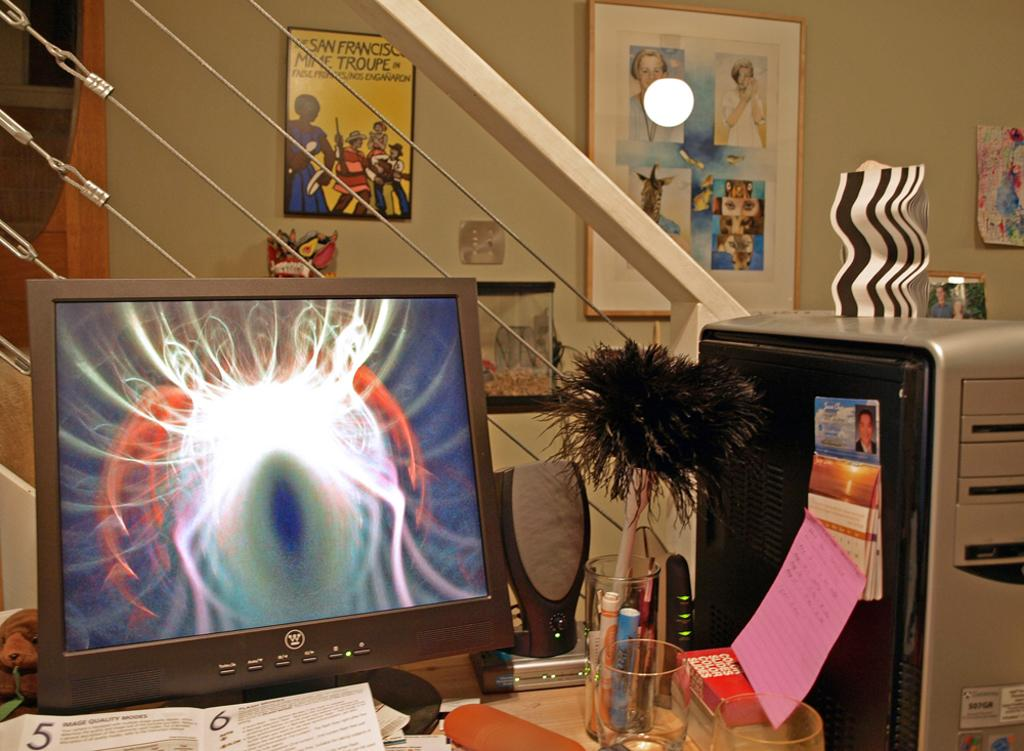<image>
Relay a brief, clear account of the picture shown. a laptop with an eyeball on the screen with the label 'w' on it 